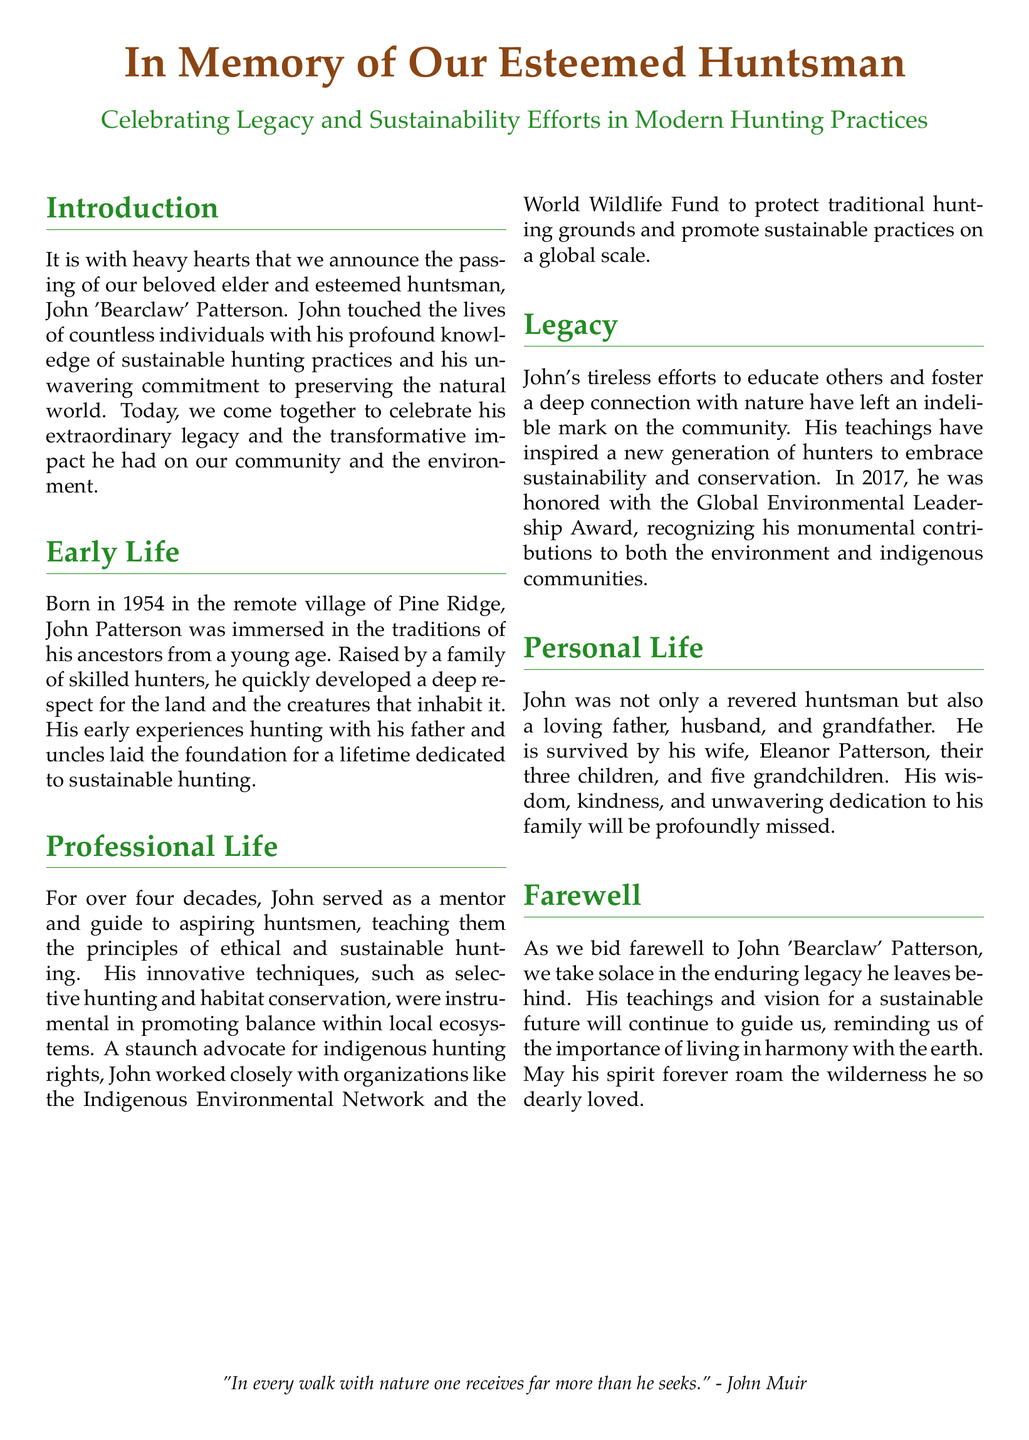What is the name of the esteemed huntsman? The document introduces John 'Bearclaw' Patterson as the esteemed huntsman being remembered.
Answer: John 'Bearclaw' Patterson What year was John Patterson born? The early life section states that John was born in 1954.
Answer: 1954 In which village was John Patterson born? The document mentions that he was born in the remote village of Pine Ridge.
Answer: Pine Ridge What award did John receive in 2017? The legacy section notes that John was honored with the Global Environmental Leadership Award in 2017.
Answer: Global Environmental Leadership Award How many children did John have? The personal life section indicates that John is survived by three children.
Answer: three What was one of John’s innovative techniques? The document states that John employed selective hunting as one of his innovative techniques.
Answer: selective hunting Who is John Patterson's wife? In the personal life section, it is mentioned that his wife is Eleanor Patterson.
Answer: Eleanor Patterson Which organizations did John work with? The professional life section lists the Indigenous Environmental Network and the World Wildlife Fund among the organizations he worked with.
Answer: Indigenous Environmental Network, World Wildlife Fund What is a key theme expressed in John’s legacy? The legacy section emphasizes that John's teachings inspired a new generation to embrace sustainability and conservation.
Answer: sustainability and conservation 